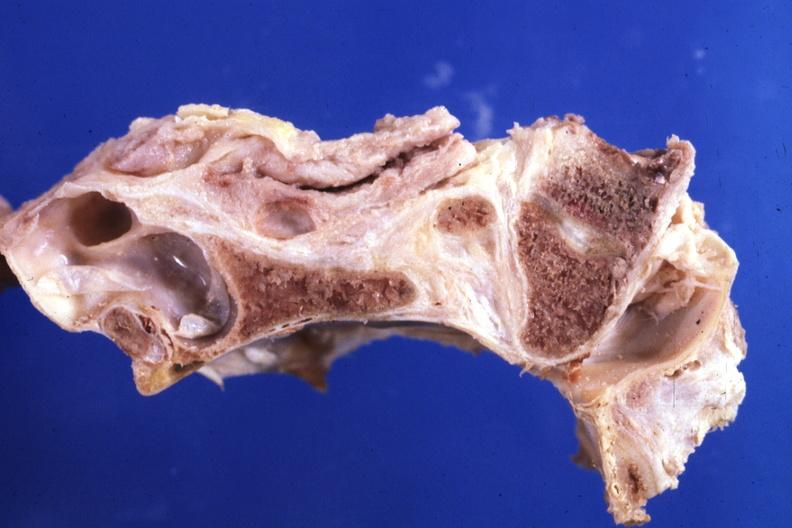s exact cause present?
Answer the question using a single word or phrase. No 